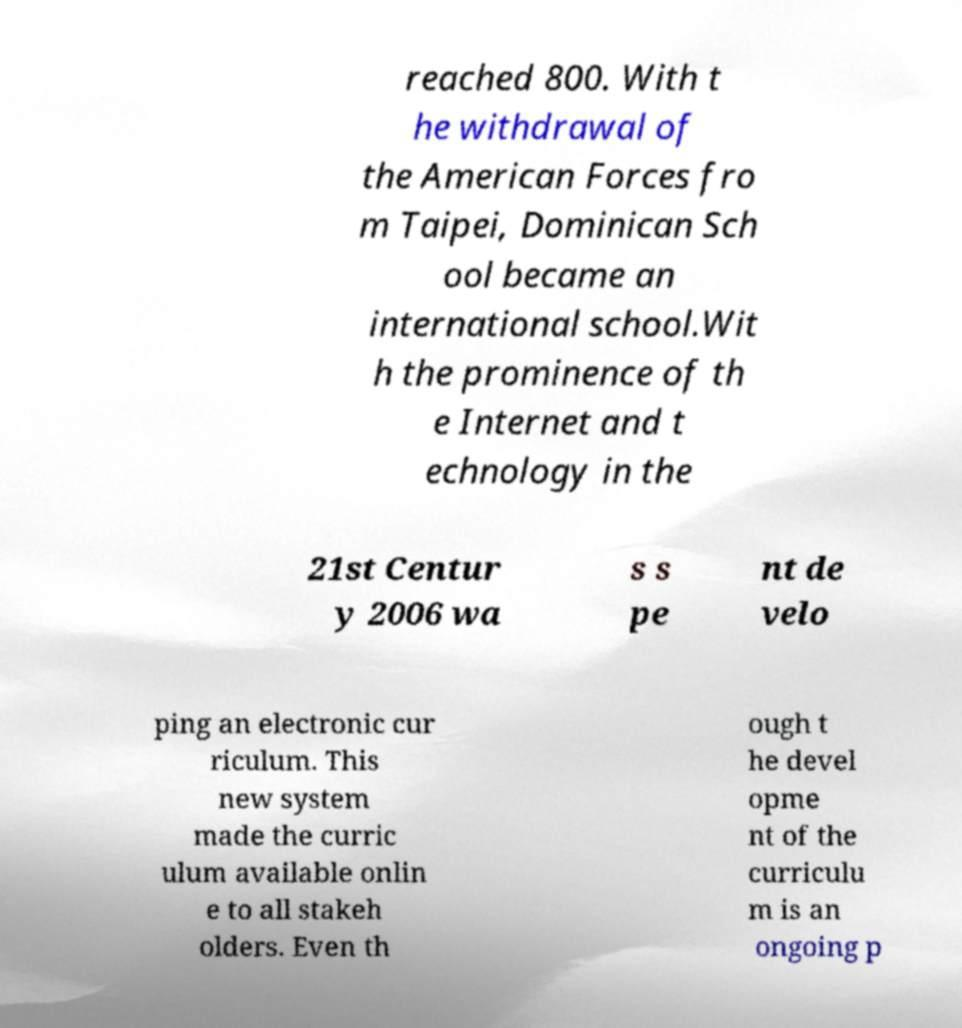Could you assist in decoding the text presented in this image and type it out clearly? reached 800. With t he withdrawal of the American Forces fro m Taipei, Dominican Sch ool became an international school.Wit h the prominence of th e Internet and t echnology in the 21st Centur y 2006 wa s s pe nt de velo ping an electronic cur riculum. This new system made the curric ulum available onlin e to all stakeh olders. Even th ough t he devel opme nt of the curriculu m is an ongoing p 